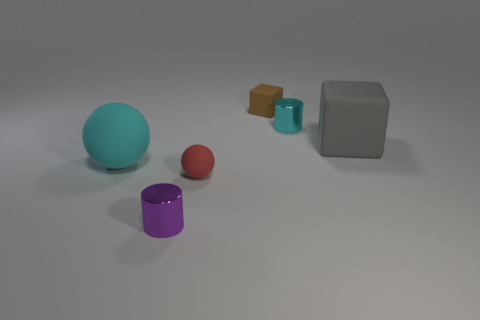Add 2 small rubber balls. How many objects exist? 8 Subtract all red balls. How many balls are left? 1 Add 4 red spheres. How many red spheres are left? 5 Add 5 big cyan objects. How many big cyan objects exist? 6 Subtract 0 yellow cylinders. How many objects are left? 6 Subtract all cylinders. How many objects are left? 4 Subtract 2 cylinders. How many cylinders are left? 0 Subtract all yellow blocks. Subtract all brown spheres. How many blocks are left? 2 Subtract all cyan cylinders. How many purple balls are left? 0 Subtract all red spheres. Subtract all brown matte cubes. How many objects are left? 4 